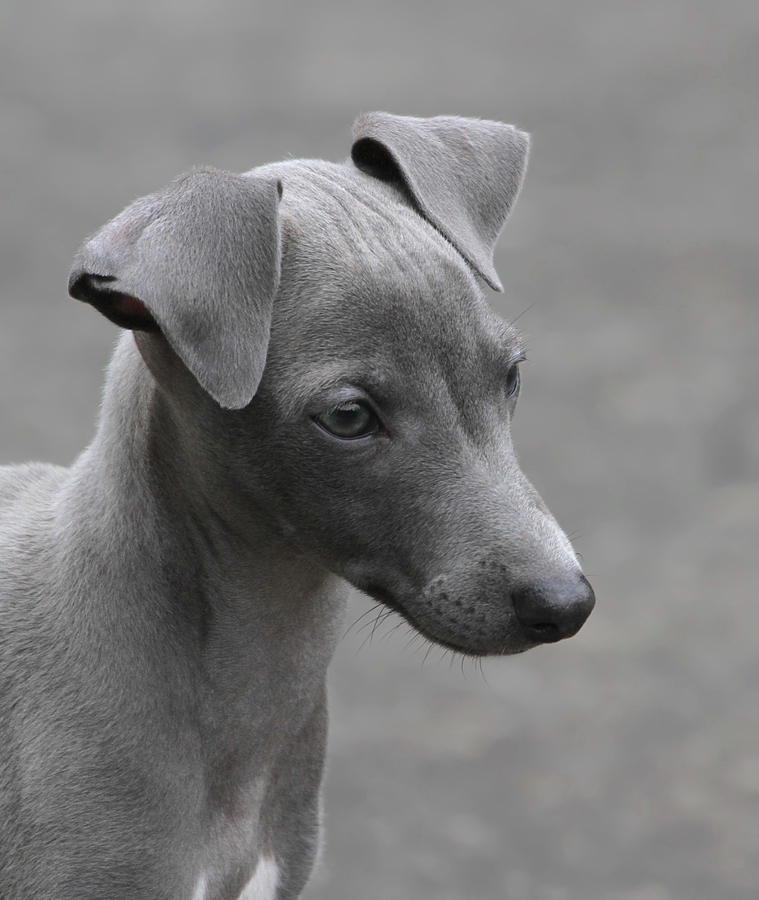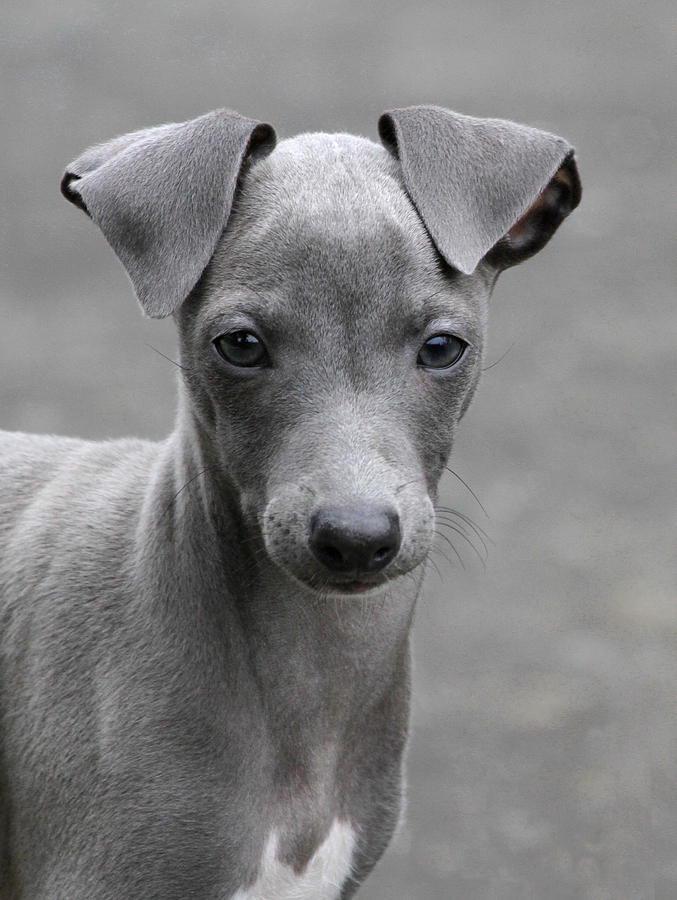The first image is the image on the left, the second image is the image on the right. For the images shown, is this caption "In 1 of the images, 1 dog is facing forward indoors." true? Answer yes or no. No. The first image is the image on the left, the second image is the image on the right. For the images shown, is this caption "There is a fence behind a dog." true? Answer yes or no. No. 